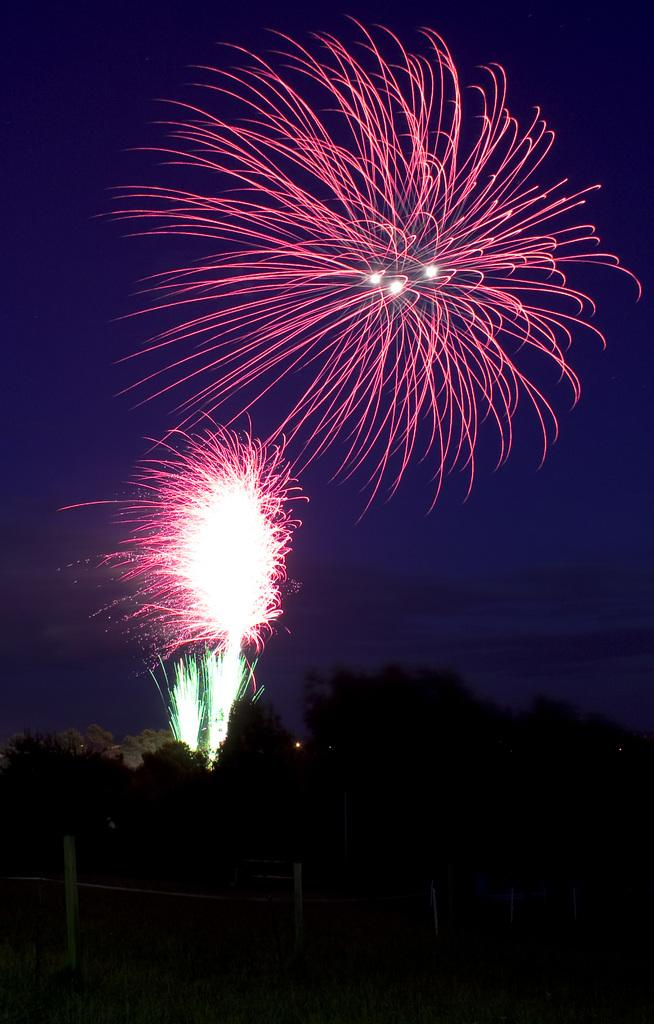What can be seen in the sky in the image? There are sparkles in the sky. What type of vegetation is visible at the bottom of the image? Trees are visible at the bottom of the image. What type of sheet is used to cover the sparkles in the image? There is no sheet present in the image, and the sparkles are not covered. How many stitches are visible on the trees in the image? There are no stitches visible on the trees in the image; they are natural vegetation. 